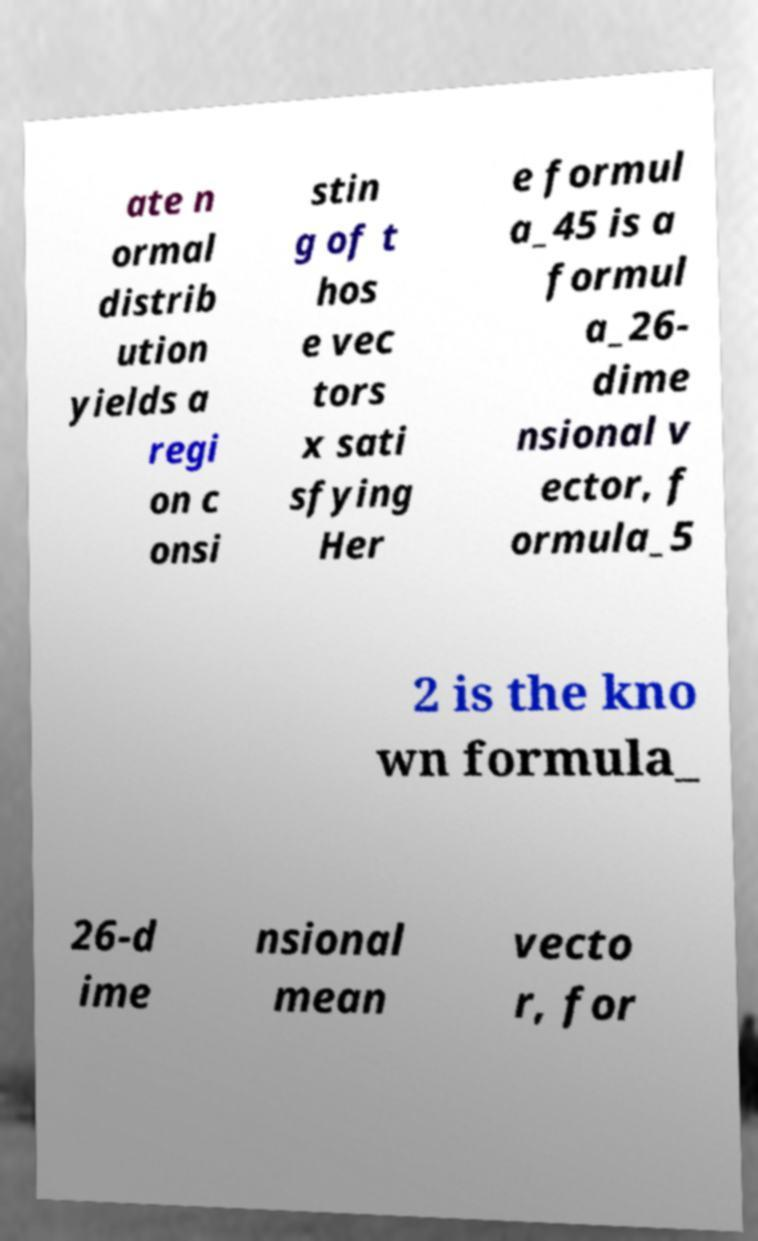Could you extract and type out the text from this image? ate n ormal distrib ution yields a regi on c onsi stin g of t hos e vec tors x sati sfying Her e formul a_45 is a formul a_26- dime nsional v ector, f ormula_5 2 is the kno wn formula_ 26-d ime nsional mean vecto r, for 